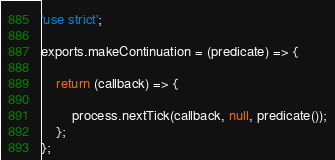<code> <loc_0><loc_0><loc_500><loc_500><_JavaScript_>'use strict';

exports.makeContinuation = (predicate) => {

    return (callback) => {

        process.nextTick(callback, null, predicate());
    };
};
</code> 